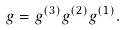Convert formula to latex. <formula><loc_0><loc_0><loc_500><loc_500>g = g ^ { ( 3 ) } g ^ { ( 2 ) } g ^ { ( 1 ) } .</formula> 